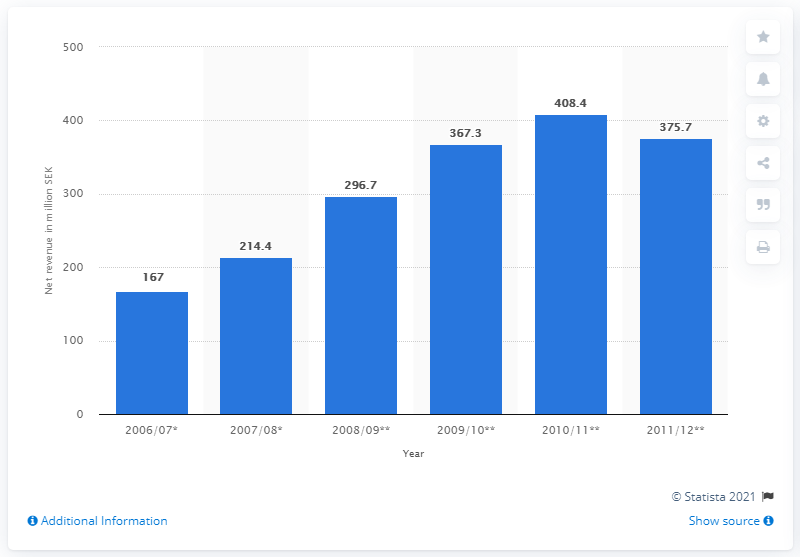Specify some key components in this picture. In the 2009/2010 fiscal year, the net revenue of WESC was 367.3 million dollars. 